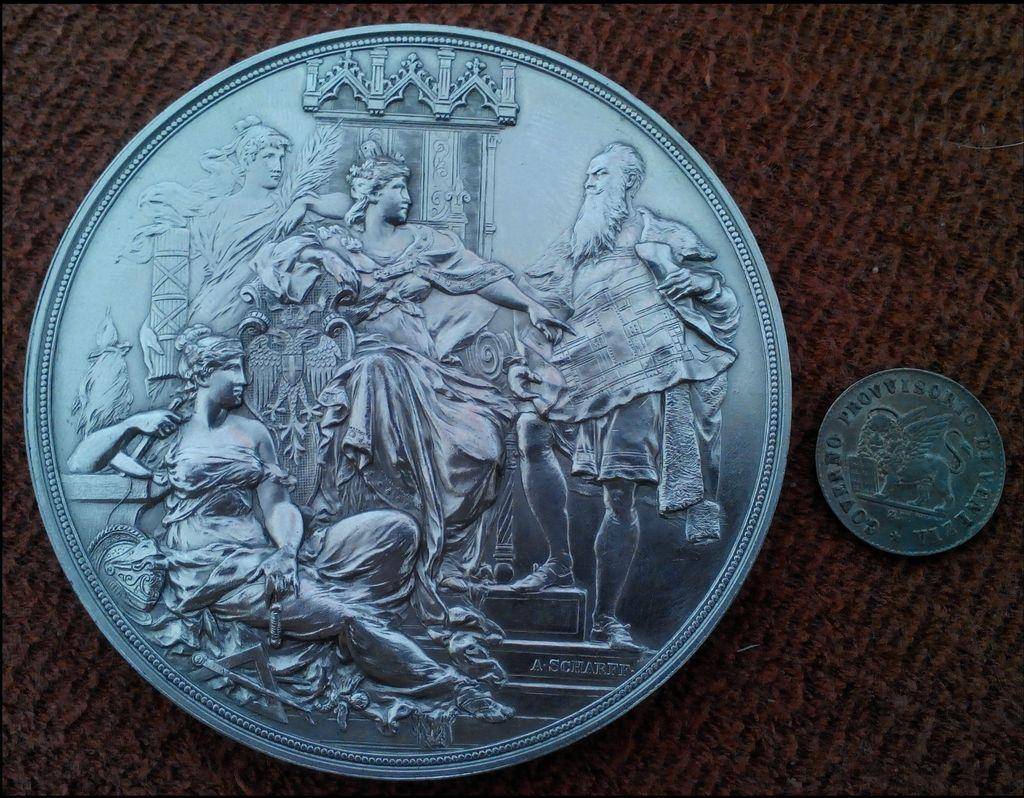What is located on the left side of the image? There is a big coin on the left side of the image. What is located on the right side of the image? There is a small coin on the right side of the image. What can be seen on both coins? Both coins have engravings of sculptures. What type of drug can be seen in the image? There is no drug present in the image; it features two coins with engravings of sculptures. Can you tell me how many arches are visible in the image? There are no arches visible in the image; it only contains two coins with engravings of sculptures. 